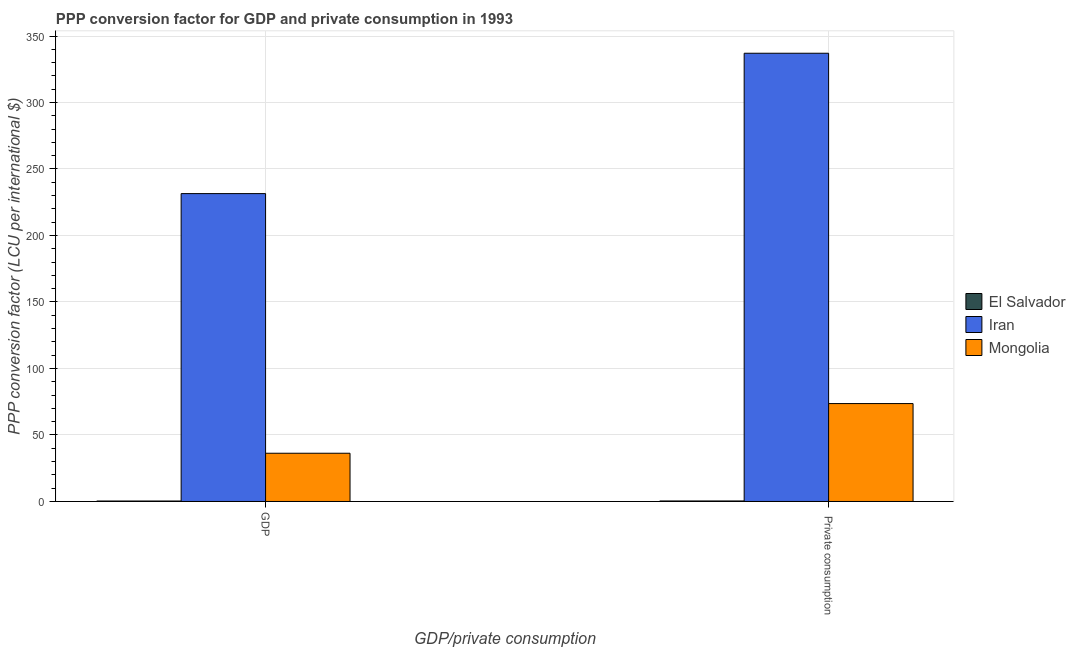How many groups of bars are there?
Make the answer very short. 2. What is the label of the 1st group of bars from the left?
Give a very brief answer. GDP. What is the ppp conversion factor for private consumption in El Salvador?
Offer a very short reply. 0.38. Across all countries, what is the maximum ppp conversion factor for gdp?
Provide a short and direct response. 231.5. Across all countries, what is the minimum ppp conversion factor for private consumption?
Provide a short and direct response. 0.38. In which country was the ppp conversion factor for gdp maximum?
Offer a terse response. Iran. In which country was the ppp conversion factor for gdp minimum?
Keep it short and to the point. El Salvador. What is the total ppp conversion factor for private consumption in the graph?
Give a very brief answer. 411.05. What is the difference between the ppp conversion factor for gdp in El Salvador and that in Iran?
Give a very brief answer. -231.15. What is the difference between the ppp conversion factor for private consumption in El Salvador and the ppp conversion factor for gdp in Iran?
Your answer should be compact. -231.12. What is the average ppp conversion factor for gdp per country?
Your answer should be very brief. 89.37. What is the difference between the ppp conversion factor for gdp and ppp conversion factor for private consumption in Mongolia?
Offer a very short reply. -37.35. In how many countries, is the ppp conversion factor for gdp greater than 110 LCU?
Keep it short and to the point. 1. What is the ratio of the ppp conversion factor for private consumption in Mongolia to that in Iran?
Offer a terse response. 0.22. Is the ppp conversion factor for private consumption in Mongolia less than that in El Salvador?
Your answer should be very brief. No. In how many countries, is the ppp conversion factor for gdp greater than the average ppp conversion factor for gdp taken over all countries?
Give a very brief answer. 1. What does the 1st bar from the left in GDP represents?
Your answer should be very brief. El Salvador. What does the 1st bar from the right in  Private consumption represents?
Make the answer very short. Mongolia. What is the difference between two consecutive major ticks on the Y-axis?
Keep it short and to the point. 50. Are the values on the major ticks of Y-axis written in scientific E-notation?
Provide a short and direct response. No. Does the graph contain grids?
Provide a succinct answer. Yes. Where does the legend appear in the graph?
Your response must be concise. Center right. How many legend labels are there?
Your response must be concise. 3. What is the title of the graph?
Your response must be concise. PPP conversion factor for GDP and private consumption in 1993. What is the label or title of the X-axis?
Your answer should be compact. GDP/private consumption. What is the label or title of the Y-axis?
Give a very brief answer. PPP conversion factor (LCU per international $). What is the PPP conversion factor (LCU per international $) of El Salvador in GDP?
Keep it short and to the point. 0.35. What is the PPP conversion factor (LCU per international $) in Iran in GDP?
Offer a very short reply. 231.5. What is the PPP conversion factor (LCU per international $) in Mongolia in GDP?
Provide a short and direct response. 36.27. What is the PPP conversion factor (LCU per international $) of El Salvador in  Private consumption?
Give a very brief answer. 0.38. What is the PPP conversion factor (LCU per international $) of Iran in  Private consumption?
Offer a terse response. 337.04. What is the PPP conversion factor (LCU per international $) of Mongolia in  Private consumption?
Your answer should be compact. 73.62. Across all GDP/private consumption, what is the maximum PPP conversion factor (LCU per international $) in El Salvador?
Offer a very short reply. 0.38. Across all GDP/private consumption, what is the maximum PPP conversion factor (LCU per international $) in Iran?
Offer a terse response. 337.04. Across all GDP/private consumption, what is the maximum PPP conversion factor (LCU per international $) of Mongolia?
Make the answer very short. 73.62. Across all GDP/private consumption, what is the minimum PPP conversion factor (LCU per international $) in El Salvador?
Make the answer very short. 0.35. Across all GDP/private consumption, what is the minimum PPP conversion factor (LCU per international $) of Iran?
Your response must be concise. 231.5. Across all GDP/private consumption, what is the minimum PPP conversion factor (LCU per international $) in Mongolia?
Give a very brief answer. 36.27. What is the total PPP conversion factor (LCU per international $) of El Salvador in the graph?
Keep it short and to the point. 0.73. What is the total PPP conversion factor (LCU per international $) in Iran in the graph?
Offer a terse response. 568.55. What is the total PPP conversion factor (LCU per international $) in Mongolia in the graph?
Offer a very short reply. 109.89. What is the difference between the PPP conversion factor (LCU per international $) of El Salvador in GDP and that in  Private consumption?
Your answer should be very brief. -0.03. What is the difference between the PPP conversion factor (LCU per international $) of Iran in GDP and that in  Private consumption?
Offer a terse response. -105.54. What is the difference between the PPP conversion factor (LCU per international $) in Mongolia in GDP and that in  Private consumption?
Offer a very short reply. -37.35. What is the difference between the PPP conversion factor (LCU per international $) in El Salvador in GDP and the PPP conversion factor (LCU per international $) in Iran in  Private consumption?
Give a very brief answer. -336.7. What is the difference between the PPP conversion factor (LCU per international $) of El Salvador in GDP and the PPP conversion factor (LCU per international $) of Mongolia in  Private consumption?
Provide a short and direct response. -73.27. What is the difference between the PPP conversion factor (LCU per international $) in Iran in GDP and the PPP conversion factor (LCU per international $) in Mongolia in  Private consumption?
Your response must be concise. 157.88. What is the average PPP conversion factor (LCU per international $) in El Salvador per GDP/private consumption?
Offer a very short reply. 0.37. What is the average PPP conversion factor (LCU per international $) in Iran per GDP/private consumption?
Ensure brevity in your answer.  284.27. What is the average PPP conversion factor (LCU per international $) of Mongolia per GDP/private consumption?
Ensure brevity in your answer.  54.94. What is the difference between the PPP conversion factor (LCU per international $) of El Salvador and PPP conversion factor (LCU per international $) of Iran in GDP?
Keep it short and to the point. -231.15. What is the difference between the PPP conversion factor (LCU per international $) in El Salvador and PPP conversion factor (LCU per international $) in Mongolia in GDP?
Offer a very short reply. -35.92. What is the difference between the PPP conversion factor (LCU per international $) of Iran and PPP conversion factor (LCU per international $) of Mongolia in GDP?
Ensure brevity in your answer.  195.23. What is the difference between the PPP conversion factor (LCU per international $) in El Salvador and PPP conversion factor (LCU per international $) in Iran in  Private consumption?
Offer a very short reply. -336.66. What is the difference between the PPP conversion factor (LCU per international $) in El Salvador and PPP conversion factor (LCU per international $) in Mongolia in  Private consumption?
Offer a very short reply. -73.24. What is the difference between the PPP conversion factor (LCU per international $) in Iran and PPP conversion factor (LCU per international $) in Mongolia in  Private consumption?
Keep it short and to the point. 263.43. What is the ratio of the PPP conversion factor (LCU per international $) of El Salvador in GDP to that in  Private consumption?
Provide a succinct answer. 0.91. What is the ratio of the PPP conversion factor (LCU per international $) in Iran in GDP to that in  Private consumption?
Provide a short and direct response. 0.69. What is the ratio of the PPP conversion factor (LCU per international $) in Mongolia in GDP to that in  Private consumption?
Keep it short and to the point. 0.49. What is the difference between the highest and the second highest PPP conversion factor (LCU per international $) of El Salvador?
Offer a very short reply. 0.03. What is the difference between the highest and the second highest PPP conversion factor (LCU per international $) of Iran?
Provide a succinct answer. 105.54. What is the difference between the highest and the second highest PPP conversion factor (LCU per international $) in Mongolia?
Keep it short and to the point. 37.35. What is the difference between the highest and the lowest PPP conversion factor (LCU per international $) of El Salvador?
Your answer should be compact. 0.03. What is the difference between the highest and the lowest PPP conversion factor (LCU per international $) in Iran?
Keep it short and to the point. 105.54. What is the difference between the highest and the lowest PPP conversion factor (LCU per international $) of Mongolia?
Give a very brief answer. 37.35. 